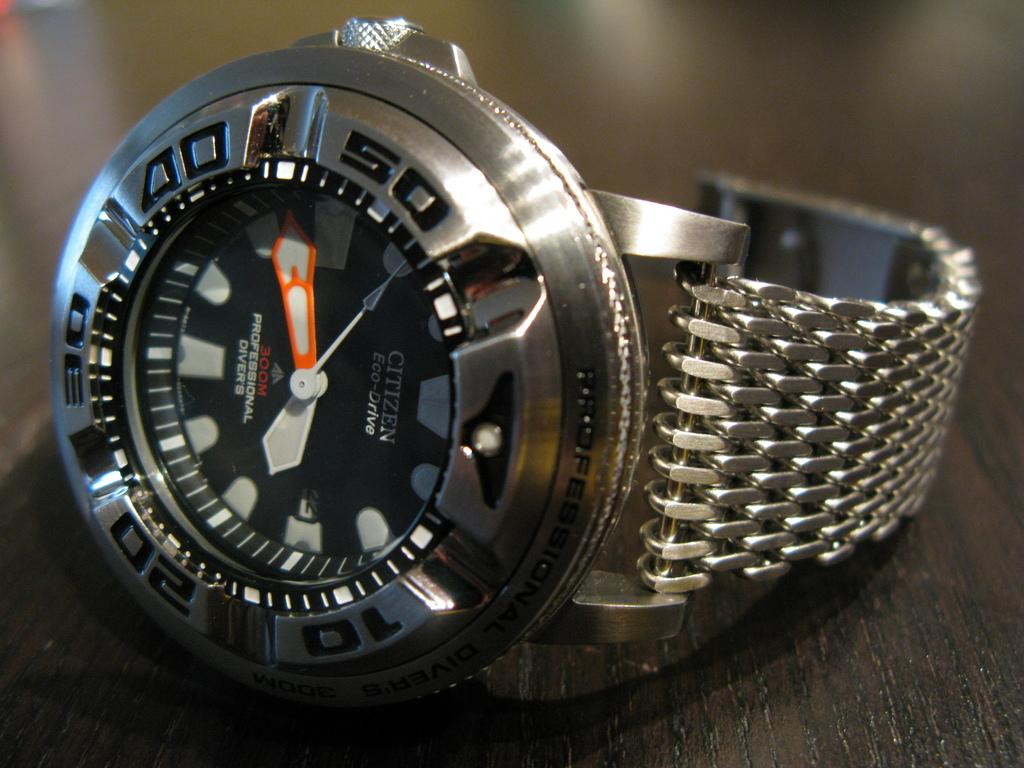<image>
Describe the image concisely. Silver and black wristwatch which says Professional Divers on the front. 